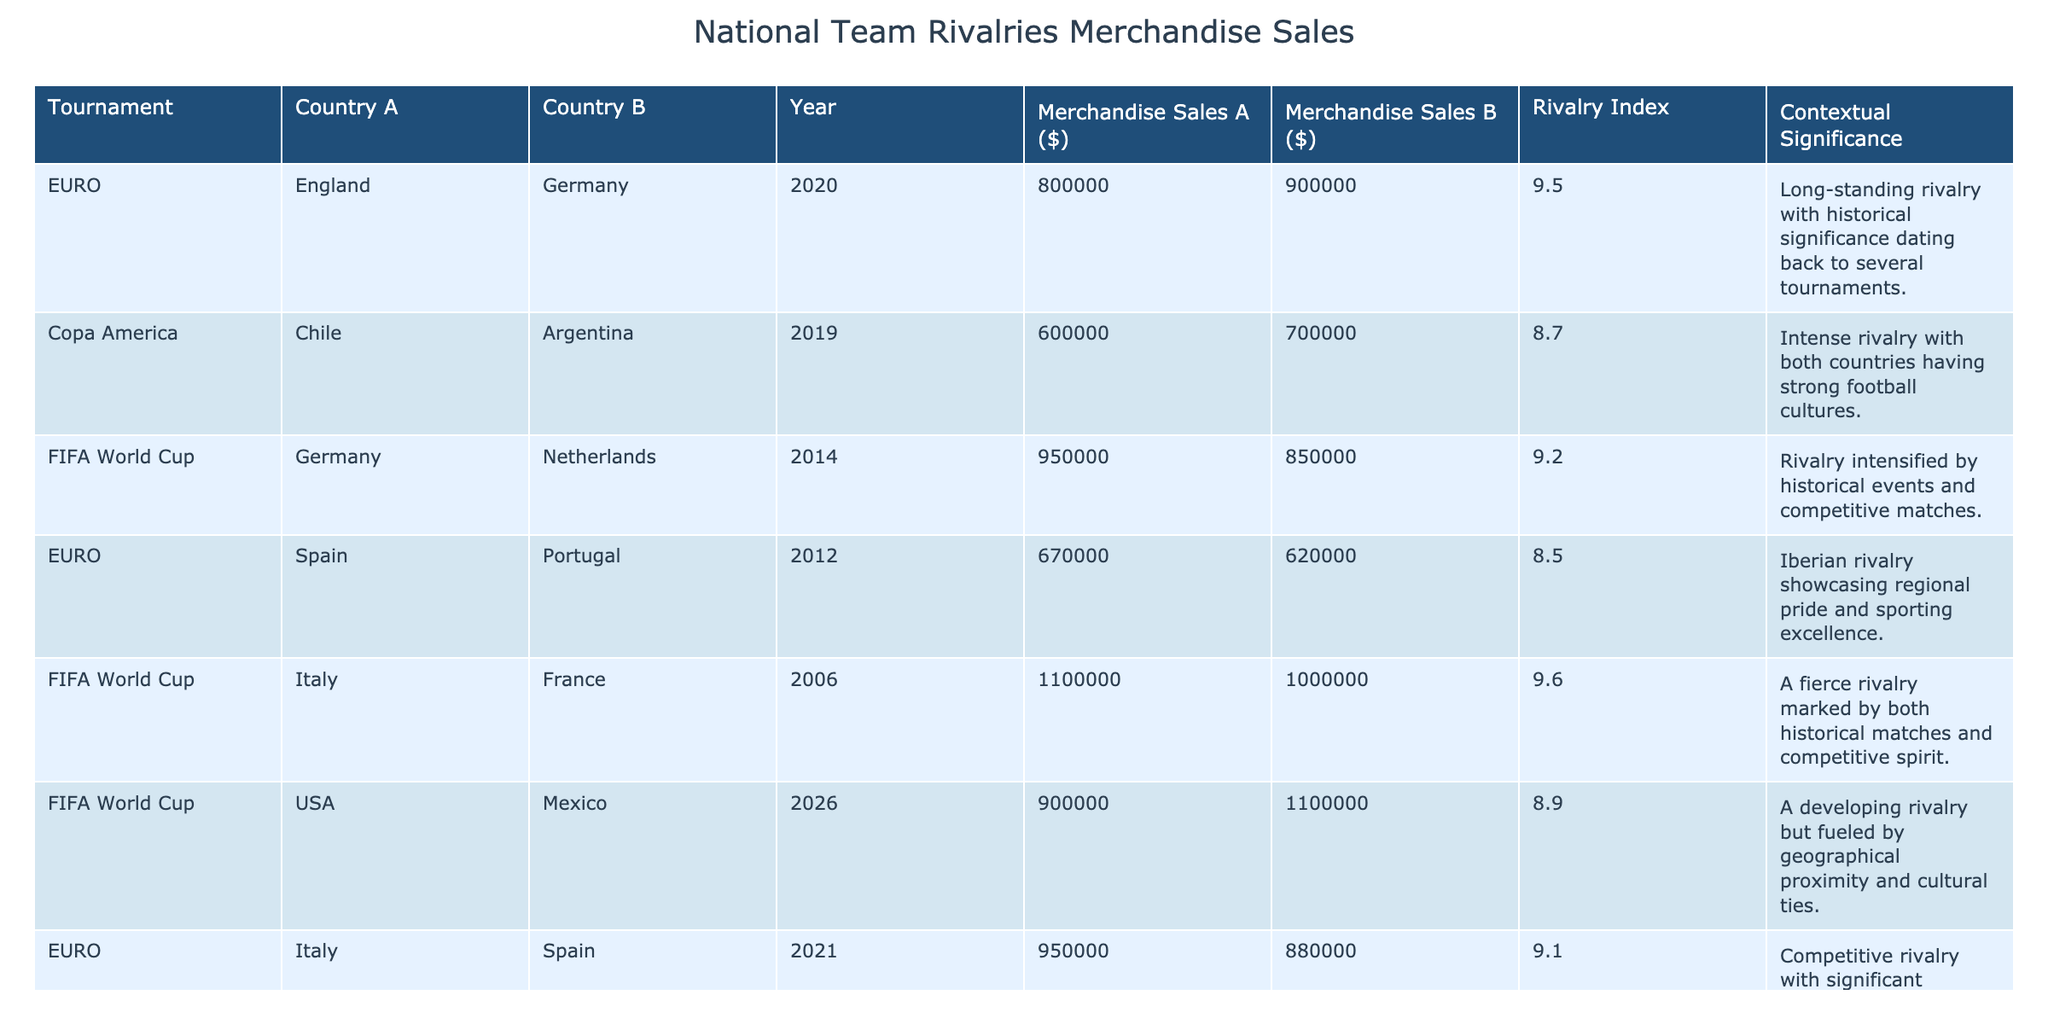What are the merchandise sales for Germany in the FIFA World Cup 2014? The table shows the merchandise sales for Germany in the FIFA World Cup 2014 as $950,000.
Answer: $950,000 Which country had higher merchandise sales in the EURO 2020 match between England and Germany? According to the table, Germany had higher merchandise sales at $900,000 compared to England's $800,000 in the EURO 2020 match.
Answer: Germany What is the rivalry index for the Chile vs Argentina match in Copa America 2019? The table lists the rivalry index for the Chile vs Argentina match in Copa America 2019 as 8.7.
Answer: 8.7 What were the total merchandise sales for USA and Mexico in FIFA World Cup 2026? The merchandise sales for USA were $900,000 and for Mexico $1,100,000. Therefore, total sales are $900,000 + $1,100,000 = $2,000,000.
Answer: $2,000,000 Which tournament shows the highest rivalry index and what is that index? By reviewing the rivalry indices, the highest is 9.6 for the Italy vs France match in FIFA World Cup 2006.
Answer: 9.6 Is the USA vs Japan match in the FIFA Women's World Cup 2019 listed with a rivalry index higher than 8.5? The table indicates that the rivalry index for the USA vs Japan match is 8.8, which is indeed higher than 8.5.
Answer: Yes What is the difference in merchandise sales between Italy and Spain in the EURO 2021? For the EURO 2021, Italy had merchandise sales of $950,000 and Spain had $880,000. The difference is $950,000 - $880,000 = $70,000.
Answer: $70,000 What is the average merchandise sale for the teams in the FIFA World Cup matches listed? The merchandise sales for FIFA World Cup matches are $1,100,000 (Italy) + $950,000 (Germany) + $900,000 (USA) + $1,000,000 (France) = $3,950,000. There are 4 entries; thus, the average is $3,950,000 / 4 = $987,500.
Answer: $987,500 Which country had the lowest merchandise sales in the Copa America 2019 match? The table shows that Chile had merchandise sales of $600,000, while Argentina had $700,000, making Chile the team with the lowest sales in that match.
Answer: Chile Is the rivalry between England and Germany considered long-standing according to the table's context? The context provided mentions a "long-standing rivalry with historical significance" for England vs Germany, confirming it as such.
Answer: Yes 